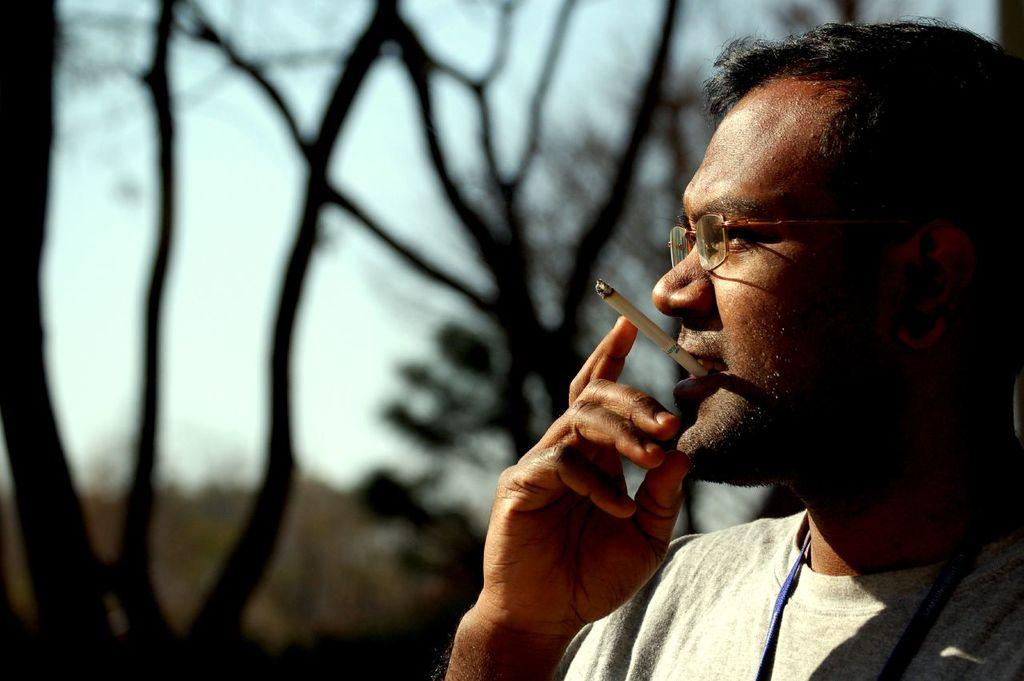Who is the main subject in the image? There is a man in the image. What is the man doing in the image? The man has a cigarette in his mouth. Can you describe the background of the image? The background of the image is blurred. What type of clothing is the man wearing? The man is wearing a t-shirt. What type of coal is being mined in the background of the image? There is no coal or mining activity present in the image; it features a man with a cigarette in his mouth and a blurred background. 